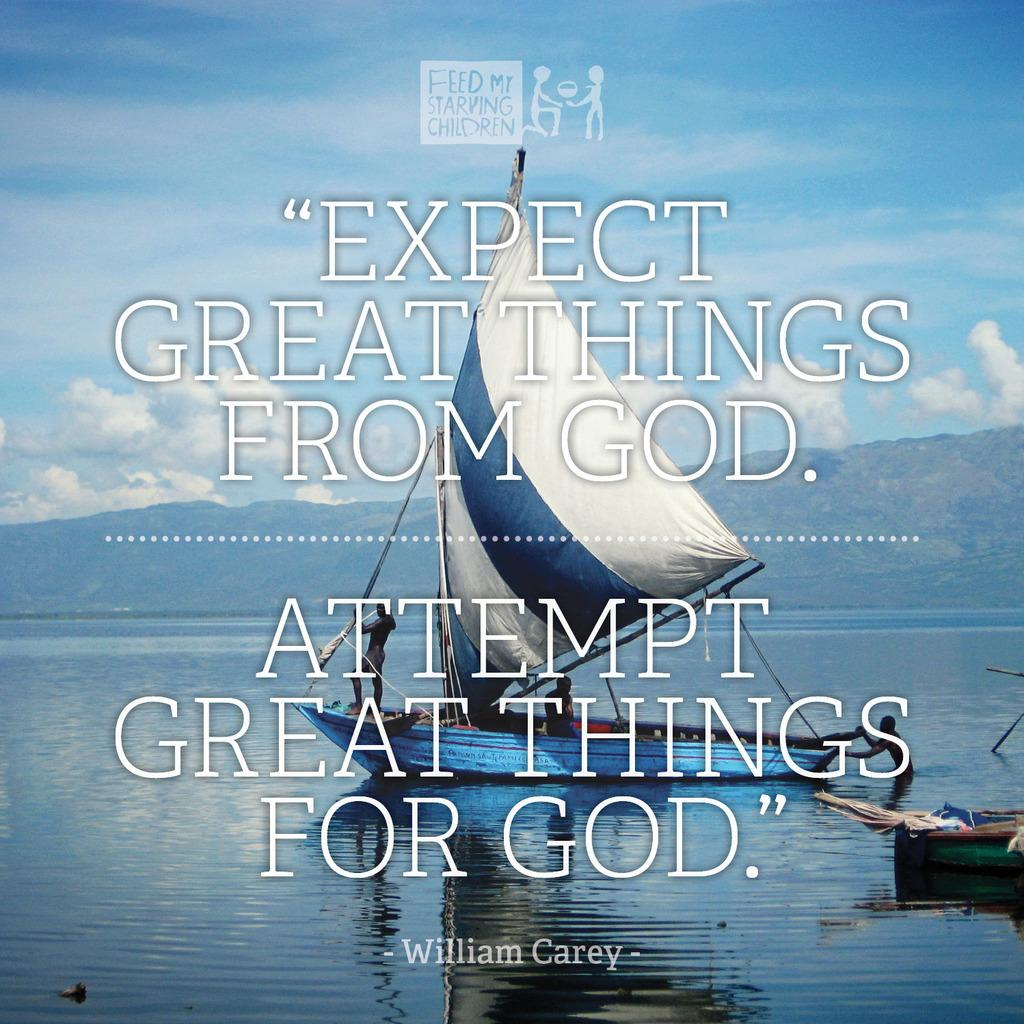Provide a one-sentence caption for the provided image. A quote in front of a boat on the water to expect great things from God. 